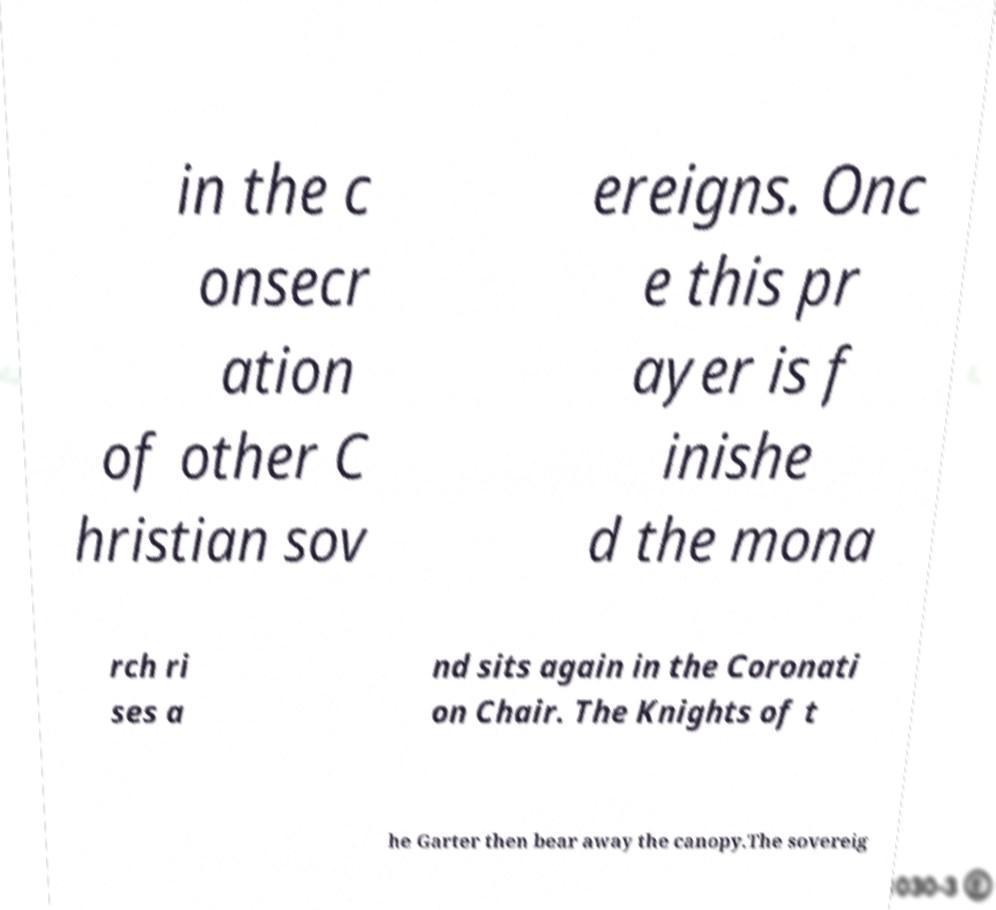Can you read and provide the text displayed in the image?This photo seems to have some interesting text. Can you extract and type it out for me? in the c onsecr ation of other C hristian sov ereigns. Onc e this pr ayer is f inishe d the mona rch ri ses a nd sits again in the Coronati on Chair. The Knights of t he Garter then bear away the canopy.The sovereig 